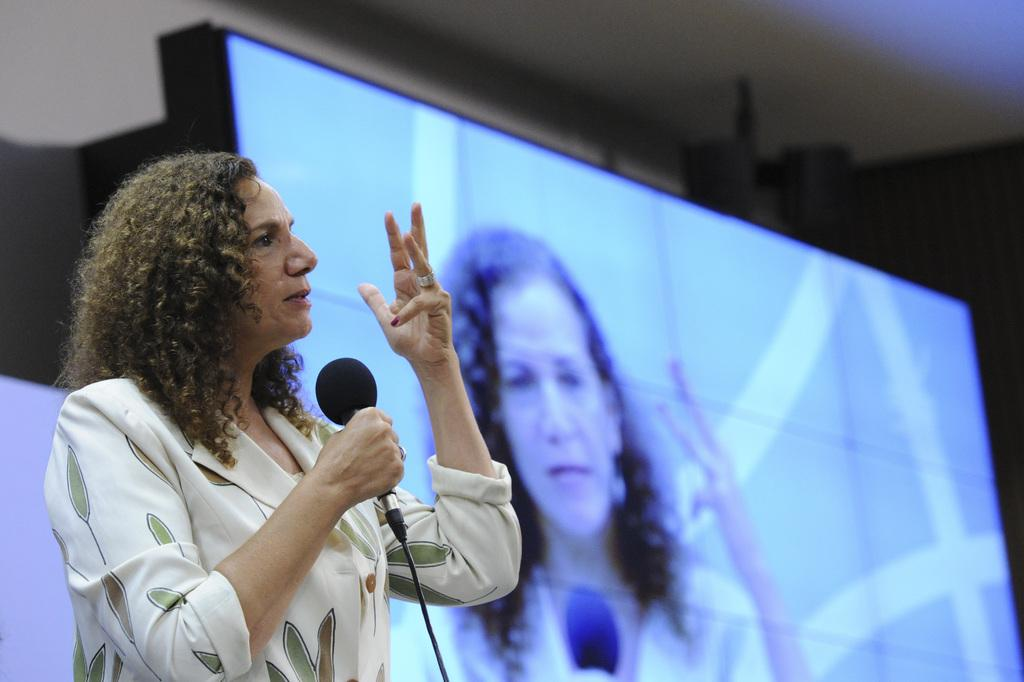Who is the main subject in the image? There is a woman in the image. What is the woman holding in her hand? The woman is holding a microphone in her hand. What is the woman doing in the image? The woman is talking. What can be seen in the background of the image? There is a screen in the background of the image. Is the woman visible on the screen? Yes, the woman is visible on the screen. What type of wilderness can be seen in the background of the image? There is no wilderness present in the image; it features a woman holding a microphone and talking, with a screen in the background. What kind of beast is visible on the screen? There is no beast visible on the screen; the woman herself is visible on the screen. 